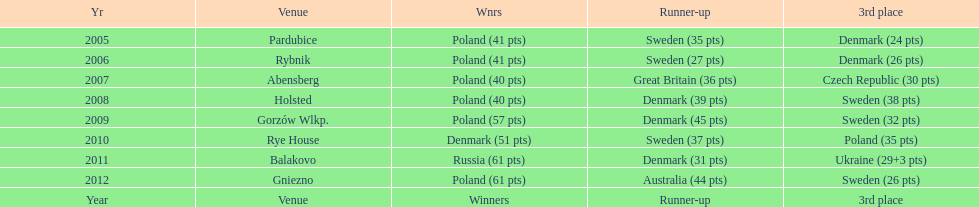Previous to 2008 how many times was sweden the runner up? 2. 